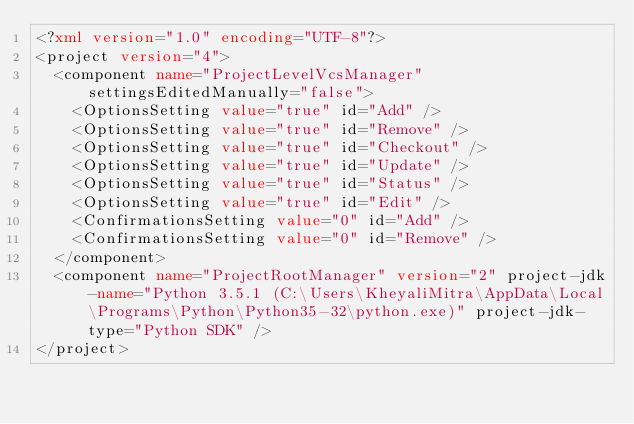<code> <loc_0><loc_0><loc_500><loc_500><_XML_><?xml version="1.0" encoding="UTF-8"?>
<project version="4">
  <component name="ProjectLevelVcsManager" settingsEditedManually="false">
    <OptionsSetting value="true" id="Add" />
    <OptionsSetting value="true" id="Remove" />
    <OptionsSetting value="true" id="Checkout" />
    <OptionsSetting value="true" id="Update" />
    <OptionsSetting value="true" id="Status" />
    <OptionsSetting value="true" id="Edit" />
    <ConfirmationsSetting value="0" id="Add" />
    <ConfirmationsSetting value="0" id="Remove" />
  </component>
  <component name="ProjectRootManager" version="2" project-jdk-name="Python 3.5.1 (C:\Users\KheyaliMitra\AppData\Local\Programs\Python\Python35-32\python.exe)" project-jdk-type="Python SDK" />
</project></code> 